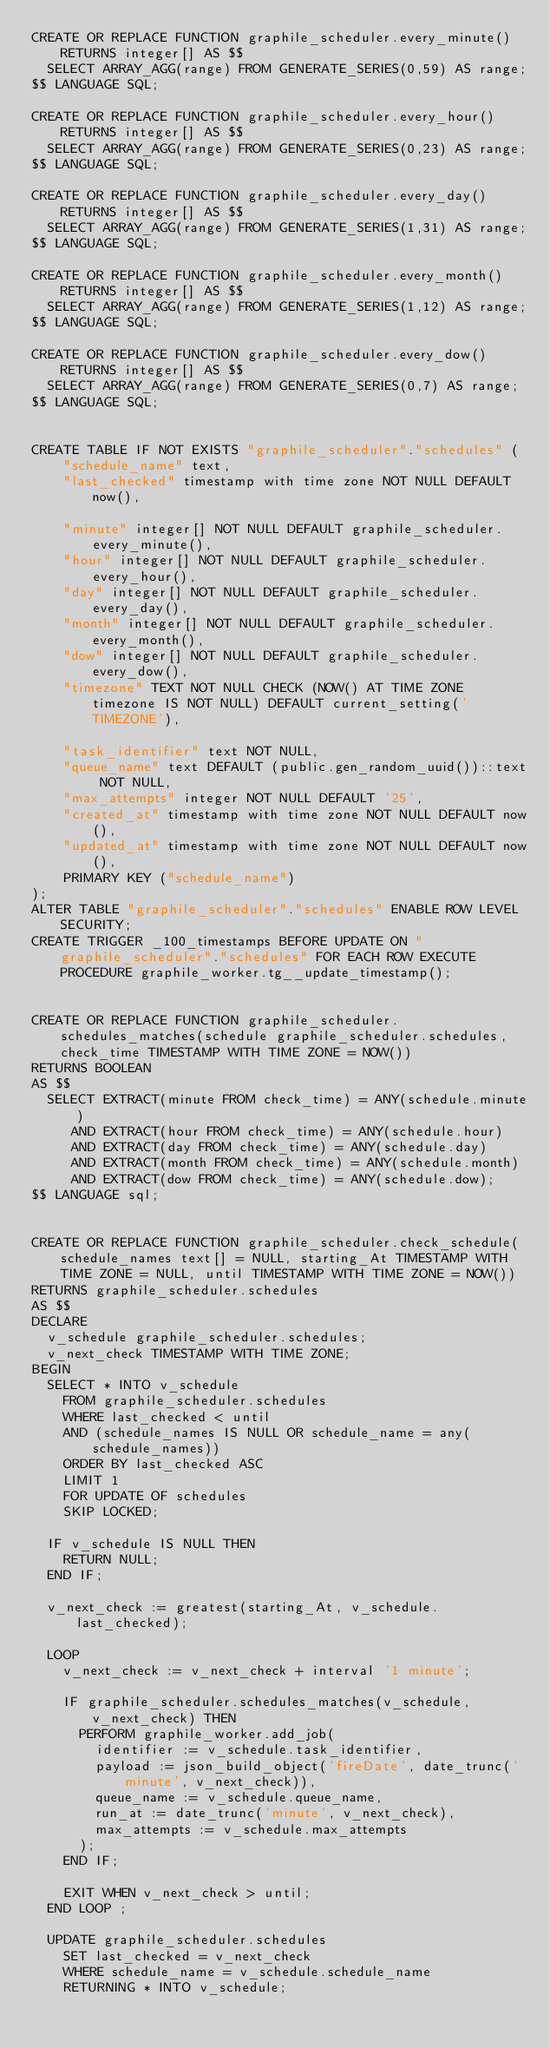<code> <loc_0><loc_0><loc_500><loc_500><_SQL_>CREATE OR REPLACE FUNCTION graphile_scheduler.every_minute() RETURNS integer[] AS $$
	SELECT ARRAY_AGG(range) FROM GENERATE_SERIES(0,59) AS range;
$$ LANGUAGE SQL;

CREATE OR REPLACE FUNCTION graphile_scheduler.every_hour() RETURNS integer[] AS $$
	SELECT ARRAY_AGG(range) FROM GENERATE_SERIES(0,23) AS range;
$$ LANGUAGE SQL;

CREATE OR REPLACE FUNCTION graphile_scheduler.every_day() RETURNS integer[] AS $$
	SELECT ARRAY_AGG(range) FROM GENERATE_SERIES(1,31) AS range;
$$ LANGUAGE SQL;

CREATE OR REPLACE FUNCTION graphile_scheduler.every_month() RETURNS integer[] AS $$
	SELECT ARRAY_AGG(range) FROM GENERATE_SERIES(1,12) AS range;
$$ LANGUAGE SQL;

CREATE OR REPLACE FUNCTION graphile_scheduler.every_dow() RETURNS integer[] AS $$
	SELECT ARRAY_AGG(range) FROM GENERATE_SERIES(0,7) AS range;
$$ LANGUAGE SQL;


CREATE TABLE IF NOT EXISTS "graphile_scheduler"."schedules" (
    "schedule_name" text,
    "last_checked" timestamp with time zone NOT NULL DEFAULT now(),
    
    "minute" integer[] NOT NULL DEFAULT graphile_scheduler.every_minute(),
    "hour" integer[] NOT NULL DEFAULT graphile_scheduler.every_hour(),
    "day" integer[] NOT NULL DEFAULT graphile_scheduler.every_day(),
    "month" integer[] NOT NULL DEFAULT graphile_scheduler.every_month(),
    "dow" integer[] NOT NULL DEFAULT graphile_scheduler.every_dow(),
    "timezone" TEXT NOT NULL CHECK (NOW() AT TIME ZONE timezone IS NOT NULL) DEFAULT current_setting('TIMEZONE'),
    
    "task_identifier" text NOT NULL,
    "queue_name" text DEFAULT (public.gen_random_uuid())::text NOT NULL,
    "max_attempts" integer NOT NULL DEFAULT '25',
    "created_at" timestamp with time zone NOT NULL DEFAULT now(),
    "updated_at" timestamp with time zone NOT NULL DEFAULT now(),
    PRIMARY KEY ("schedule_name")
);
ALTER TABLE "graphile_scheduler"."schedules" ENABLE ROW LEVEL SECURITY;
CREATE TRIGGER _100_timestamps BEFORE UPDATE ON "graphile_scheduler"."schedules" FOR EACH ROW EXECUTE PROCEDURE graphile_worker.tg__update_timestamp();


CREATE OR REPLACE FUNCTION graphile_scheduler.schedules_matches(schedule graphile_scheduler.schedules, check_time TIMESTAMP WITH TIME ZONE = NOW())
RETURNS BOOLEAN
AS $$
  SELECT EXTRACT(minute FROM check_time) = ANY(schedule.minute)
     AND EXTRACT(hour FROM check_time) = ANY(schedule.hour)
     AND EXTRACT(day FROM check_time) = ANY(schedule.day)
     AND EXTRACT(month FROM check_time) = ANY(schedule.month)
     AND EXTRACT(dow FROM check_time) = ANY(schedule.dow);
$$ LANGUAGE sql;


CREATE OR REPLACE FUNCTION graphile_scheduler.check_schedule(schedule_names text[] = NULL, starting_At TIMESTAMP WITH TIME ZONE = NULL, until TIMESTAMP WITH TIME ZONE = NOW()) 
RETURNS graphile_scheduler.schedules
AS $$
DECLARE
  v_schedule graphile_scheduler.schedules;
  v_next_check TIMESTAMP WITH TIME ZONE;
BEGIN
  SELECT * INTO v_schedule
    FROM graphile_scheduler.schedules
    WHERE last_checked < until
    AND (schedule_names IS NULL OR schedule_name = any(schedule_names))
    ORDER BY last_checked ASC
    LIMIT 1
    FOR UPDATE OF schedules
    SKIP LOCKED;
  
  IF v_schedule IS NULL THEN
    RETURN NULL;
  END IF;

  v_next_check := greatest(starting_At, v_schedule.last_checked);

  LOOP
    v_next_check := v_next_check + interval '1 minute';
    
  	IF graphile_scheduler.schedules_matches(v_schedule, v_next_check) THEN
      PERFORM graphile_worker.add_job(
        identifier := v_schedule.task_identifier,
        payload := json_build_object('fireDate', date_trunc('minute', v_next_check)),
        queue_name := v_schedule.queue_name, 
        run_at := date_trunc('minute', v_next_check), 
        max_attempts := v_schedule.max_attempts
      );
  	END IF;
  	
    EXIT WHEN v_next_check > until;
  END LOOP ;

  UPDATE graphile_scheduler.schedules
    SET last_checked = v_next_check
    WHERE schedule_name = v_schedule.schedule_name
    RETURNING * INTO v_schedule;
    </code> 